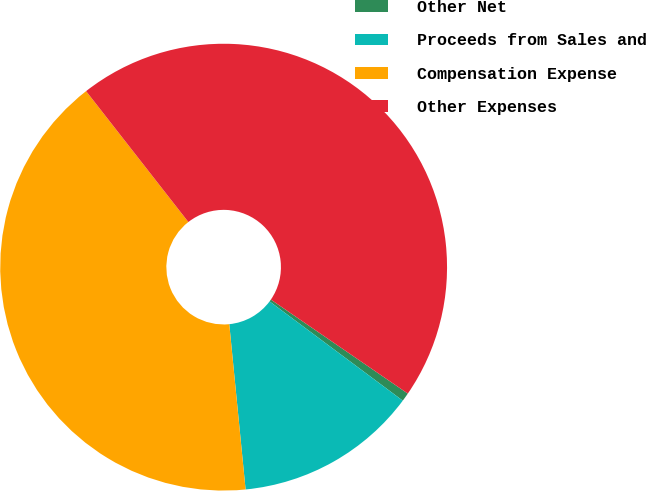<chart> <loc_0><loc_0><loc_500><loc_500><pie_chart><fcel>Other Net<fcel>Proceeds from Sales and<fcel>Compensation Expense<fcel>Other Expenses<nl><fcel>0.62%<fcel>13.24%<fcel>41.01%<fcel>45.13%<nl></chart> 